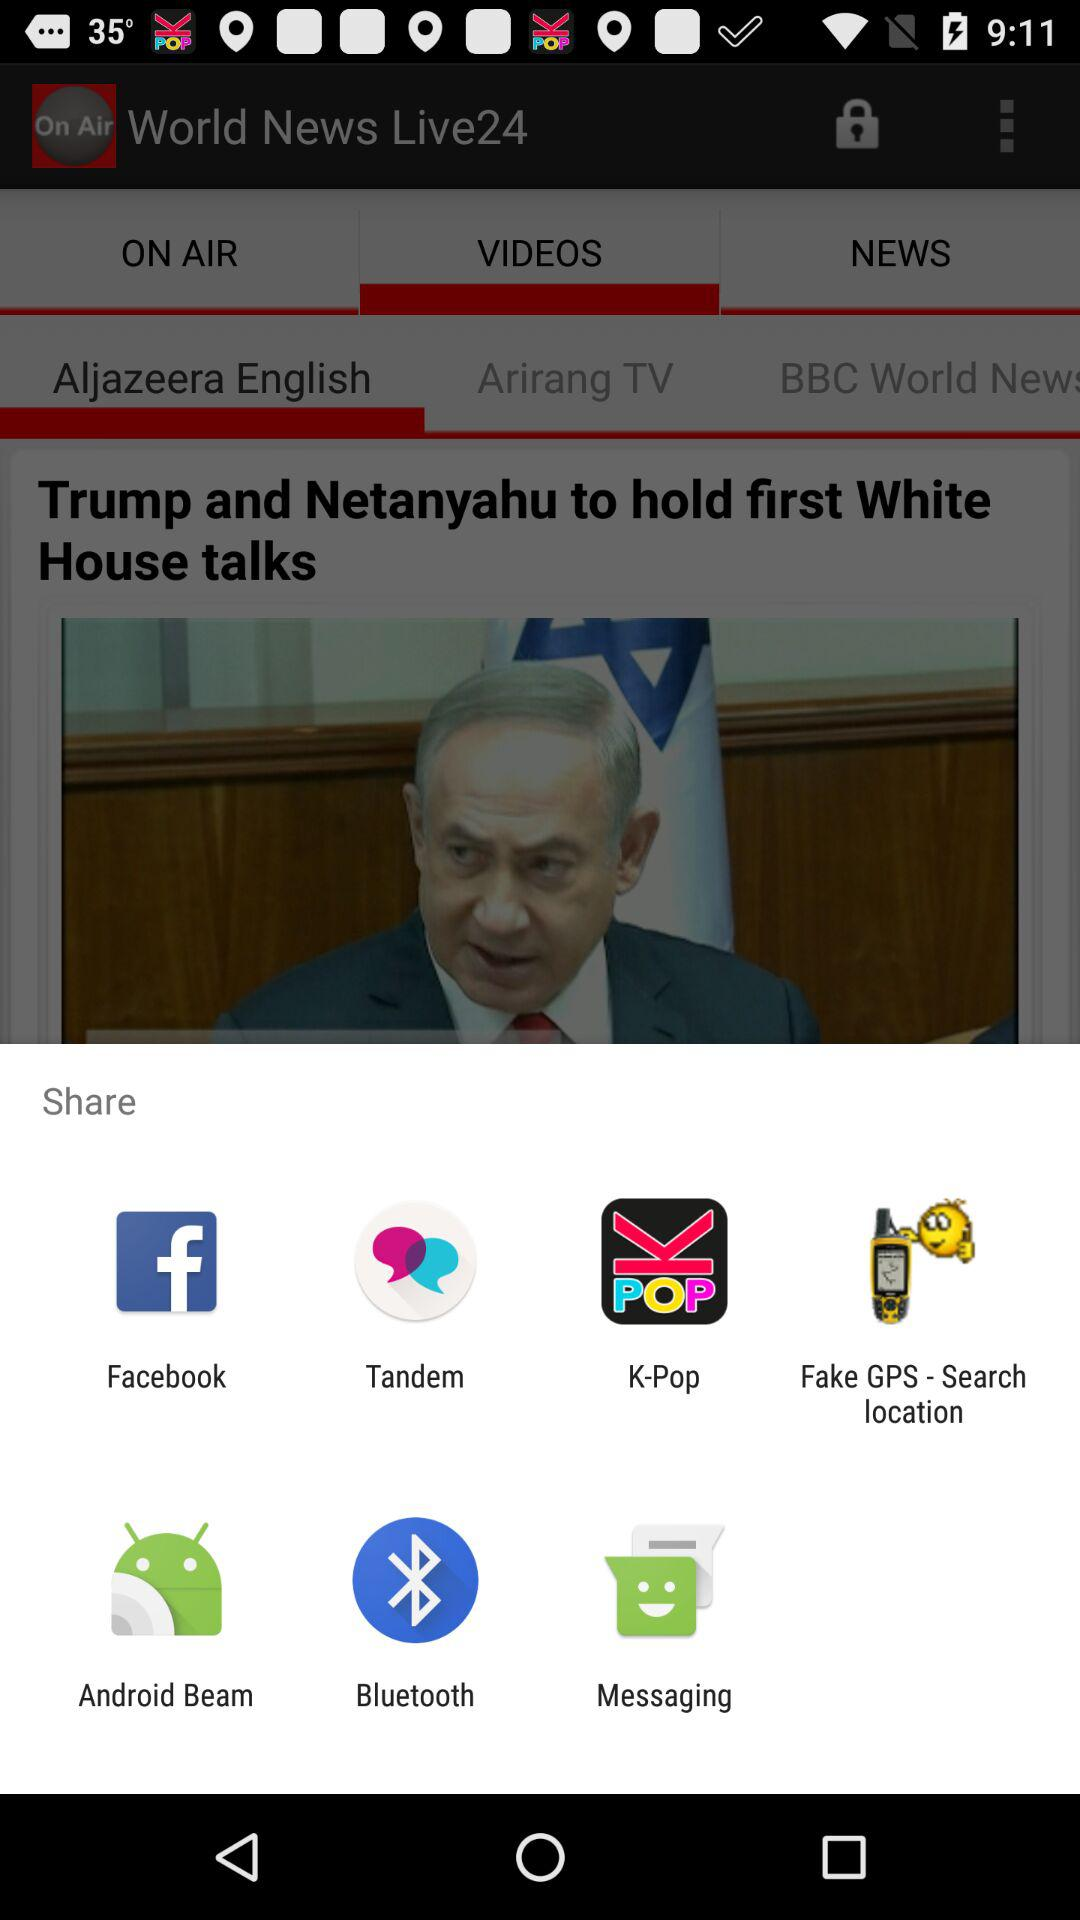Through which applications can we share the content? You can share the content through "Facebook", "Tandem", "K-Pop", "Fake GPS - Search location", "Android Beam", "Bluetooth" and "Messaging". 